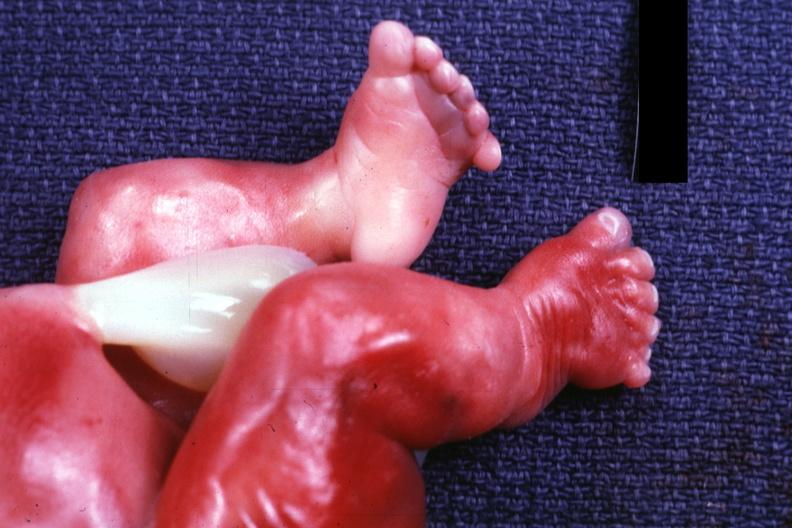what are present?
Answer the question using a single word or phrase. Extremities 